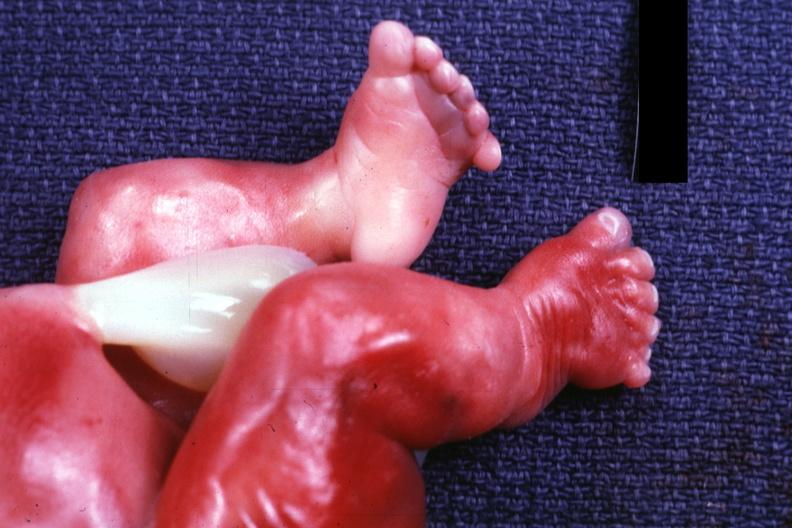what are present?
Answer the question using a single word or phrase. Extremities 